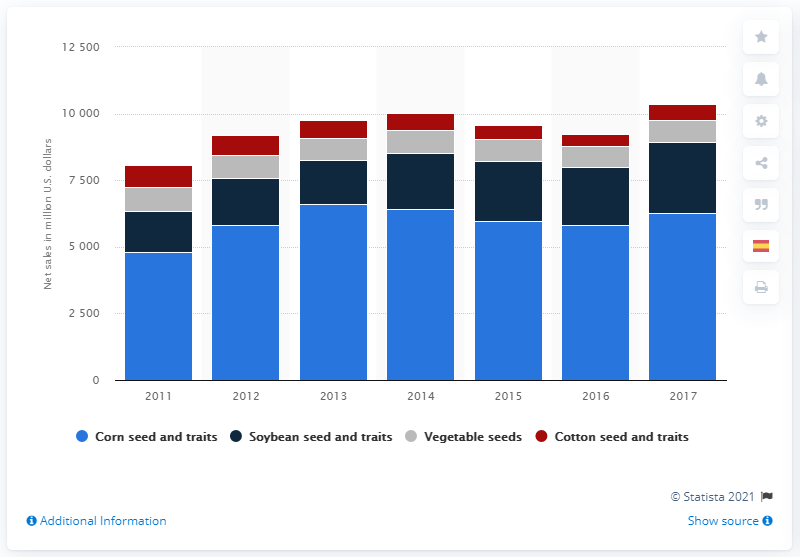Mention a couple of crucial points in this snapshot. In 2017, Monsanto's net sales from its corn seed and trait specialty were approximately $6,270 million. 